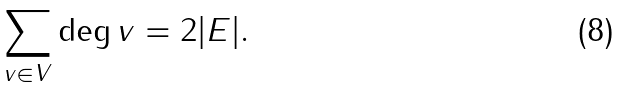Convert formula to latex. <formula><loc_0><loc_0><loc_500><loc_500>\sum _ { v \in V } \deg v = 2 | E | .</formula> 